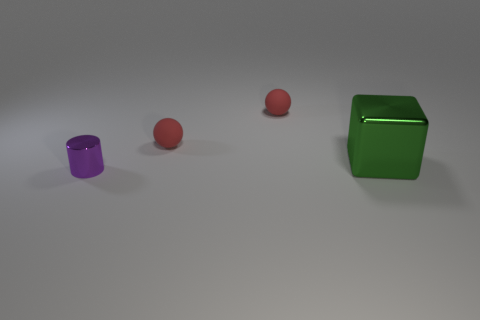Are there any other things that are the same shape as the purple shiny object?
Keep it short and to the point. No. Are there the same number of big green metal objects that are in front of the big green thing and small spheres?
Make the answer very short. No. How many other objects are the same material as the small purple thing?
Your response must be concise. 1. What is the color of the large thing that is made of the same material as the purple cylinder?
Your response must be concise. Green. Does the purple metal thing have the same shape as the large object?
Provide a short and direct response. No. Are there any things that are on the right side of the shiny thing that is right of the tiny thing that is in front of the green cube?
Offer a very short reply. No. How many tiny rubber things have the same color as the big cube?
Ensure brevity in your answer.  0. There is a purple object; are there any tiny red matte spheres behind it?
Provide a short and direct response. Yes. Does the shiny block have the same size as the cylinder?
Give a very brief answer. No. The metal thing to the left of the green shiny cube has what shape?
Keep it short and to the point. Cylinder. 